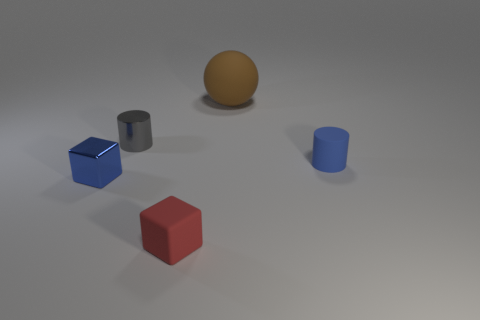There is a small matte thing that is the same color as the metal cube; what is its shape?
Offer a very short reply. Cylinder. What number of other things are the same size as the matte sphere?
Your answer should be compact. 0. Is there any other thing that has the same shape as the blue rubber object?
Your answer should be compact. Yes. Are there the same number of spheres behind the large thing and tiny green metal spheres?
Provide a short and direct response. Yes. How many small cubes have the same material as the blue cylinder?
Provide a short and direct response. 1. What color is the block that is made of the same material as the brown ball?
Your response must be concise. Red. Is the small blue shiny thing the same shape as the gray metal thing?
Give a very brief answer. No. There is a cylinder on the left side of the rubber thing on the left side of the large matte sphere; is there a red cube in front of it?
Offer a very short reply. Yes. How many rubber objects have the same color as the tiny shiny cube?
Ensure brevity in your answer.  1. What is the shape of the red object that is the same size as the shiny block?
Your answer should be very brief. Cube. 